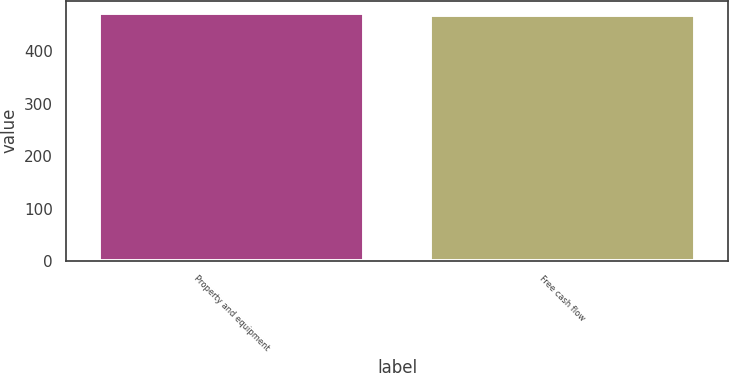<chart> <loc_0><loc_0><loc_500><loc_500><bar_chart><fcel>Property and equipment<fcel>Free cash flow<nl><fcel>473<fcel>470<nl></chart> 